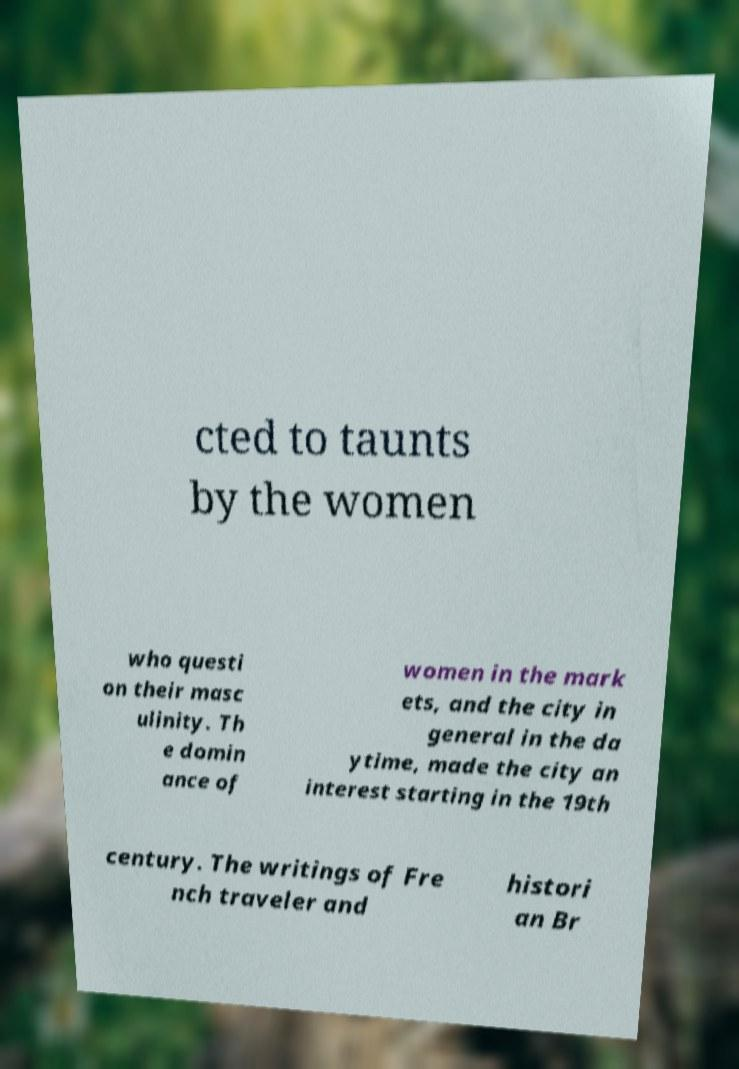I need the written content from this picture converted into text. Can you do that? cted to taunts by the women who questi on their masc ulinity. Th e domin ance of women in the mark ets, and the city in general in the da ytime, made the city an interest starting in the 19th century. The writings of Fre nch traveler and histori an Br 